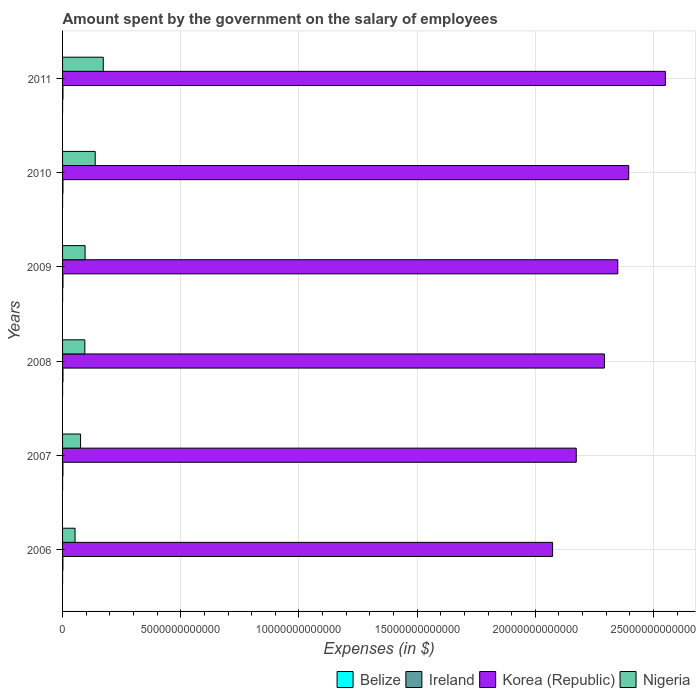How many different coloured bars are there?
Your answer should be compact. 4. How many groups of bars are there?
Provide a succinct answer. 6. Are the number of bars per tick equal to the number of legend labels?
Keep it short and to the point. Yes. Are the number of bars on each tick of the Y-axis equal?
Give a very brief answer. Yes. How many bars are there on the 6th tick from the top?
Provide a succinct answer. 4. What is the label of the 1st group of bars from the top?
Provide a short and direct response. 2011. In how many cases, is the number of bars for a given year not equal to the number of legend labels?
Offer a very short reply. 0. What is the amount spent on the salary of employees by the government in Belize in 2011?
Offer a terse response. 2.96e+08. Across all years, what is the maximum amount spent on the salary of employees by the government in Nigeria?
Provide a succinct answer. 1.72e+12. Across all years, what is the minimum amount spent on the salary of employees by the government in Korea (Republic)?
Make the answer very short. 2.07e+13. In which year was the amount spent on the salary of employees by the government in Korea (Republic) minimum?
Offer a very short reply. 2006. What is the total amount spent on the salary of employees by the government in Belize in the graph?
Give a very brief answer. 1.55e+09. What is the difference between the amount spent on the salary of employees by the government in Ireland in 2008 and that in 2009?
Ensure brevity in your answer.  2.99e+08. What is the difference between the amount spent on the salary of employees by the government in Korea (Republic) in 2009 and the amount spent on the salary of employees by the government in Nigeria in 2007?
Your response must be concise. 2.27e+13. What is the average amount spent on the salary of employees by the government in Ireland per year?
Give a very brief answer. 1.65e+1. In the year 2010, what is the difference between the amount spent on the salary of employees by the government in Belize and amount spent on the salary of employees by the government in Nigeria?
Give a very brief answer. -1.38e+12. In how many years, is the amount spent on the salary of employees by the government in Nigeria greater than 17000000000000 $?
Your answer should be very brief. 0. What is the ratio of the amount spent on the salary of employees by the government in Ireland in 2006 to that in 2008?
Provide a succinct answer. 0.81. Is the amount spent on the salary of employees by the government in Belize in 2007 less than that in 2010?
Ensure brevity in your answer.  Yes. What is the difference between the highest and the second highest amount spent on the salary of employees by the government in Ireland?
Make the answer very short. 2.99e+08. What is the difference between the highest and the lowest amount spent on the salary of employees by the government in Korea (Republic)?
Offer a terse response. 4.77e+12. Is it the case that in every year, the sum of the amount spent on the salary of employees by the government in Ireland and amount spent on the salary of employees by the government in Belize is greater than the sum of amount spent on the salary of employees by the government in Korea (Republic) and amount spent on the salary of employees by the government in Nigeria?
Provide a short and direct response. No. What does the 4th bar from the top in 2011 represents?
Ensure brevity in your answer.  Belize. What does the 1st bar from the bottom in 2009 represents?
Offer a terse response. Belize. How many bars are there?
Offer a terse response. 24. Are all the bars in the graph horizontal?
Your answer should be very brief. Yes. How many years are there in the graph?
Offer a terse response. 6. What is the difference between two consecutive major ticks on the X-axis?
Offer a terse response. 5.00e+12. Are the values on the major ticks of X-axis written in scientific E-notation?
Ensure brevity in your answer.  No. Where does the legend appear in the graph?
Give a very brief answer. Bottom right. What is the title of the graph?
Keep it short and to the point. Amount spent by the government on the salary of employees. Does "Latin America(developing only)" appear as one of the legend labels in the graph?
Give a very brief answer. No. What is the label or title of the X-axis?
Make the answer very short. Expenses (in $). What is the label or title of the Y-axis?
Make the answer very short. Years. What is the Expenses (in $) in Belize in 2006?
Keep it short and to the point. 2.19e+08. What is the Expenses (in $) of Ireland in 2006?
Offer a very short reply. 1.45e+1. What is the Expenses (in $) of Korea (Republic) in 2006?
Make the answer very short. 2.07e+13. What is the Expenses (in $) of Nigeria in 2006?
Offer a terse response. 5.28e+11. What is the Expenses (in $) in Belize in 2007?
Keep it short and to the point. 2.34e+08. What is the Expenses (in $) of Ireland in 2007?
Give a very brief answer. 1.59e+1. What is the Expenses (in $) in Korea (Republic) in 2007?
Make the answer very short. 2.17e+13. What is the Expenses (in $) in Nigeria in 2007?
Make the answer very short. 7.61e+11. What is the Expenses (in $) of Belize in 2008?
Keep it short and to the point. 2.50e+08. What is the Expenses (in $) of Ireland in 2008?
Your response must be concise. 1.80e+1. What is the Expenses (in $) of Korea (Republic) in 2008?
Ensure brevity in your answer.  2.29e+13. What is the Expenses (in $) in Nigeria in 2008?
Your response must be concise. 9.43e+11. What is the Expenses (in $) in Belize in 2009?
Offer a very short reply. 2.74e+08. What is the Expenses (in $) of Ireland in 2009?
Your response must be concise. 1.77e+1. What is the Expenses (in $) in Korea (Republic) in 2009?
Make the answer very short. 2.35e+13. What is the Expenses (in $) of Nigeria in 2009?
Give a very brief answer. 9.53e+11. What is the Expenses (in $) of Belize in 2010?
Make the answer very short. 2.79e+08. What is the Expenses (in $) of Ireland in 2010?
Your answer should be compact. 1.65e+1. What is the Expenses (in $) in Korea (Republic) in 2010?
Ensure brevity in your answer.  2.40e+13. What is the Expenses (in $) in Nigeria in 2010?
Provide a succinct answer. 1.38e+12. What is the Expenses (in $) in Belize in 2011?
Provide a short and direct response. 2.96e+08. What is the Expenses (in $) in Ireland in 2011?
Offer a very short reply. 1.63e+1. What is the Expenses (in $) of Korea (Republic) in 2011?
Your answer should be very brief. 2.55e+13. What is the Expenses (in $) in Nigeria in 2011?
Ensure brevity in your answer.  1.72e+12. Across all years, what is the maximum Expenses (in $) in Belize?
Offer a very short reply. 2.96e+08. Across all years, what is the maximum Expenses (in $) in Ireland?
Offer a terse response. 1.80e+1. Across all years, what is the maximum Expenses (in $) of Korea (Republic)?
Provide a succinct answer. 2.55e+13. Across all years, what is the maximum Expenses (in $) in Nigeria?
Provide a short and direct response. 1.72e+12. Across all years, what is the minimum Expenses (in $) in Belize?
Your answer should be compact. 2.19e+08. Across all years, what is the minimum Expenses (in $) of Ireland?
Keep it short and to the point. 1.45e+1. Across all years, what is the minimum Expenses (in $) in Korea (Republic)?
Offer a very short reply. 2.07e+13. Across all years, what is the minimum Expenses (in $) of Nigeria?
Provide a short and direct response. 5.28e+11. What is the total Expenses (in $) of Belize in the graph?
Offer a terse response. 1.55e+09. What is the total Expenses (in $) of Ireland in the graph?
Provide a short and direct response. 9.89e+1. What is the total Expenses (in $) of Korea (Republic) in the graph?
Your answer should be very brief. 1.38e+14. What is the total Expenses (in $) of Nigeria in the graph?
Ensure brevity in your answer.  6.29e+12. What is the difference between the Expenses (in $) of Belize in 2006 and that in 2007?
Your answer should be very brief. -1.45e+07. What is the difference between the Expenses (in $) in Ireland in 2006 and that in 2007?
Your answer should be very brief. -1.43e+09. What is the difference between the Expenses (in $) in Korea (Republic) in 2006 and that in 2007?
Provide a short and direct response. -1.00e+12. What is the difference between the Expenses (in $) in Nigeria in 2006 and that in 2007?
Keep it short and to the point. -2.33e+11. What is the difference between the Expenses (in $) of Belize in 2006 and that in 2008?
Provide a succinct answer. -3.06e+07. What is the difference between the Expenses (in $) in Ireland in 2006 and that in 2008?
Provide a succinct answer. -3.45e+09. What is the difference between the Expenses (in $) in Korea (Republic) in 2006 and that in 2008?
Your response must be concise. -2.19e+12. What is the difference between the Expenses (in $) in Nigeria in 2006 and that in 2008?
Provide a short and direct response. -4.15e+11. What is the difference between the Expenses (in $) of Belize in 2006 and that in 2009?
Give a very brief answer. -5.46e+07. What is the difference between the Expenses (in $) of Ireland in 2006 and that in 2009?
Your answer should be compact. -3.15e+09. What is the difference between the Expenses (in $) of Korea (Republic) in 2006 and that in 2009?
Your answer should be very brief. -2.76e+12. What is the difference between the Expenses (in $) in Nigeria in 2006 and that in 2009?
Your answer should be compact. -4.25e+11. What is the difference between the Expenses (in $) of Belize in 2006 and that in 2010?
Give a very brief answer. -5.96e+07. What is the difference between the Expenses (in $) of Ireland in 2006 and that in 2010?
Offer a terse response. -2.00e+09. What is the difference between the Expenses (in $) in Korea (Republic) in 2006 and that in 2010?
Your response must be concise. -3.22e+12. What is the difference between the Expenses (in $) in Nigeria in 2006 and that in 2010?
Your answer should be compact. -8.53e+11. What is the difference between the Expenses (in $) of Belize in 2006 and that in 2011?
Your answer should be compact. -7.70e+07. What is the difference between the Expenses (in $) of Ireland in 2006 and that in 2011?
Provide a succinct answer. -1.82e+09. What is the difference between the Expenses (in $) of Korea (Republic) in 2006 and that in 2011?
Make the answer very short. -4.77e+12. What is the difference between the Expenses (in $) of Nigeria in 2006 and that in 2011?
Ensure brevity in your answer.  -1.19e+12. What is the difference between the Expenses (in $) in Belize in 2007 and that in 2008?
Provide a short and direct response. -1.62e+07. What is the difference between the Expenses (in $) in Ireland in 2007 and that in 2008?
Your response must be concise. -2.02e+09. What is the difference between the Expenses (in $) of Korea (Republic) in 2007 and that in 2008?
Provide a succinct answer. -1.19e+12. What is the difference between the Expenses (in $) in Nigeria in 2007 and that in 2008?
Your answer should be compact. -1.82e+11. What is the difference between the Expenses (in $) of Belize in 2007 and that in 2009?
Keep it short and to the point. -4.01e+07. What is the difference between the Expenses (in $) of Ireland in 2007 and that in 2009?
Offer a terse response. -1.73e+09. What is the difference between the Expenses (in $) in Korea (Republic) in 2007 and that in 2009?
Your response must be concise. -1.76e+12. What is the difference between the Expenses (in $) of Nigeria in 2007 and that in 2009?
Your answer should be compact. -1.91e+11. What is the difference between the Expenses (in $) of Belize in 2007 and that in 2010?
Your response must be concise. -4.51e+07. What is the difference between the Expenses (in $) in Ireland in 2007 and that in 2010?
Offer a terse response. -5.68e+08. What is the difference between the Expenses (in $) in Korea (Republic) in 2007 and that in 2010?
Keep it short and to the point. -2.22e+12. What is the difference between the Expenses (in $) in Nigeria in 2007 and that in 2010?
Give a very brief answer. -6.19e+11. What is the difference between the Expenses (in $) in Belize in 2007 and that in 2011?
Provide a succinct answer. -6.25e+07. What is the difference between the Expenses (in $) of Ireland in 2007 and that in 2011?
Offer a terse response. -3.91e+08. What is the difference between the Expenses (in $) of Korea (Republic) in 2007 and that in 2011?
Make the answer very short. -3.77e+12. What is the difference between the Expenses (in $) in Nigeria in 2007 and that in 2011?
Provide a succinct answer. -9.61e+11. What is the difference between the Expenses (in $) in Belize in 2008 and that in 2009?
Your response must be concise. -2.39e+07. What is the difference between the Expenses (in $) in Ireland in 2008 and that in 2009?
Your answer should be very brief. 2.99e+08. What is the difference between the Expenses (in $) in Korea (Republic) in 2008 and that in 2009?
Make the answer very short. -5.65e+11. What is the difference between the Expenses (in $) in Nigeria in 2008 and that in 2009?
Ensure brevity in your answer.  -9.80e+09. What is the difference between the Expenses (in $) in Belize in 2008 and that in 2010?
Give a very brief answer. -2.89e+07. What is the difference between the Expenses (in $) of Ireland in 2008 and that in 2010?
Make the answer very short. 1.46e+09. What is the difference between the Expenses (in $) in Korea (Republic) in 2008 and that in 2010?
Ensure brevity in your answer.  -1.03e+12. What is the difference between the Expenses (in $) of Nigeria in 2008 and that in 2010?
Ensure brevity in your answer.  -4.38e+11. What is the difference between the Expenses (in $) of Belize in 2008 and that in 2011?
Give a very brief answer. -4.63e+07. What is the difference between the Expenses (in $) in Ireland in 2008 and that in 2011?
Your response must be concise. 1.63e+09. What is the difference between the Expenses (in $) in Korea (Republic) in 2008 and that in 2011?
Your response must be concise. -2.58e+12. What is the difference between the Expenses (in $) of Nigeria in 2008 and that in 2011?
Make the answer very short. -7.80e+11. What is the difference between the Expenses (in $) in Belize in 2009 and that in 2010?
Give a very brief answer. -5.02e+06. What is the difference between the Expenses (in $) in Ireland in 2009 and that in 2010?
Offer a very short reply. 1.16e+09. What is the difference between the Expenses (in $) of Korea (Republic) in 2009 and that in 2010?
Offer a very short reply. -4.62e+11. What is the difference between the Expenses (in $) in Nigeria in 2009 and that in 2010?
Provide a succinct answer. -4.28e+11. What is the difference between the Expenses (in $) in Belize in 2009 and that in 2011?
Offer a terse response. -2.24e+07. What is the difference between the Expenses (in $) in Ireland in 2009 and that in 2011?
Offer a very short reply. 1.33e+09. What is the difference between the Expenses (in $) in Korea (Republic) in 2009 and that in 2011?
Make the answer very short. -2.01e+12. What is the difference between the Expenses (in $) of Nigeria in 2009 and that in 2011?
Give a very brief answer. -7.70e+11. What is the difference between the Expenses (in $) in Belize in 2010 and that in 2011?
Offer a terse response. -1.74e+07. What is the difference between the Expenses (in $) of Ireland in 2010 and that in 2011?
Give a very brief answer. 1.77e+08. What is the difference between the Expenses (in $) in Korea (Republic) in 2010 and that in 2011?
Your response must be concise. -1.55e+12. What is the difference between the Expenses (in $) of Nigeria in 2010 and that in 2011?
Provide a succinct answer. -3.42e+11. What is the difference between the Expenses (in $) of Belize in 2006 and the Expenses (in $) of Ireland in 2007?
Provide a succinct answer. -1.57e+1. What is the difference between the Expenses (in $) in Belize in 2006 and the Expenses (in $) in Korea (Republic) in 2007?
Your response must be concise. -2.17e+13. What is the difference between the Expenses (in $) in Belize in 2006 and the Expenses (in $) in Nigeria in 2007?
Your answer should be very brief. -7.61e+11. What is the difference between the Expenses (in $) of Ireland in 2006 and the Expenses (in $) of Korea (Republic) in 2007?
Your answer should be compact. -2.17e+13. What is the difference between the Expenses (in $) in Ireland in 2006 and the Expenses (in $) in Nigeria in 2007?
Your response must be concise. -7.47e+11. What is the difference between the Expenses (in $) of Korea (Republic) in 2006 and the Expenses (in $) of Nigeria in 2007?
Ensure brevity in your answer.  2.00e+13. What is the difference between the Expenses (in $) in Belize in 2006 and the Expenses (in $) in Ireland in 2008?
Offer a very short reply. -1.77e+1. What is the difference between the Expenses (in $) of Belize in 2006 and the Expenses (in $) of Korea (Republic) in 2008?
Offer a terse response. -2.29e+13. What is the difference between the Expenses (in $) in Belize in 2006 and the Expenses (in $) in Nigeria in 2008?
Give a very brief answer. -9.43e+11. What is the difference between the Expenses (in $) in Ireland in 2006 and the Expenses (in $) in Korea (Republic) in 2008?
Make the answer very short. -2.29e+13. What is the difference between the Expenses (in $) of Ireland in 2006 and the Expenses (in $) of Nigeria in 2008?
Provide a short and direct response. -9.28e+11. What is the difference between the Expenses (in $) of Korea (Republic) in 2006 and the Expenses (in $) of Nigeria in 2008?
Ensure brevity in your answer.  1.98e+13. What is the difference between the Expenses (in $) of Belize in 2006 and the Expenses (in $) of Ireland in 2009?
Provide a short and direct response. -1.74e+1. What is the difference between the Expenses (in $) in Belize in 2006 and the Expenses (in $) in Korea (Republic) in 2009?
Your answer should be very brief. -2.35e+13. What is the difference between the Expenses (in $) in Belize in 2006 and the Expenses (in $) in Nigeria in 2009?
Offer a very short reply. -9.52e+11. What is the difference between the Expenses (in $) of Ireland in 2006 and the Expenses (in $) of Korea (Republic) in 2009?
Provide a short and direct response. -2.35e+13. What is the difference between the Expenses (in $) of Ireland in 2006 and the Expenses (in $) of Nigeria in 2009?
Provide a succinct answer. -9.38e+11. What is the difference between the Expenses (in $) in Korea (Republic) in 2006 and the Expenses (in $) in Nigeria in 2009?
Your response must be concise. 1.98e+13. What is the difference between the Expenses (in $) of Belize in 2006 and the Expenses (in $) of Ireland in 2010?
Your answer should be very brief. -1.63e+1. What is the difference between the Expenses (in $) in Belize in 2006 and the Expenses (in $) in Korea (Republic) in 2010?
Provide a short and direct response. -2.40e+13. What is the difference between the Expenses (in $) in Belize in 2006 and the Expenses (in $) in Nigeria in 2010?
Your response must be concise. -1.38e+12. What is the difference between the Expenses (in $) in Ireland in 2006 and the Expenses (in $) in Korea (Republic) in 2010?
Your answer should be very brief. -2.39e+13. What is the difference between the Expenses (in $) of Ireland in 2006 and the Expenses (in $) of Nigeria in 2010?
Make the answer very short. -1.37e+12. What is the difference between the Expenses (in $) of Korea (Republic) in 2006 and the Expenses (in $) of Nigeria in 2010?
Your answer should be very brief. 1.94e+13. What is the difference between the Expenses (in $) in Belize in 2006 and the Expenses (in $) in Ireland in 2011?
Your response must be concise. -1.61e+1. What is the difference between the Expenses (in $) in Belize in 2006 and the Expenses (in $) in Korea (Republic) in 2011?
Provide a short and direct response. -2.55e+13. What is the difference between the Expenses (in $) of Belize in 2006 and the Expenses (in $) of Nigeria in 2011?
Your response must be concise. -1.72e+12. What is the difference between the Expenses (in $) in Ireland in 2006 and the Expenses (in $) in Korea (Republic) in 2011?
Provide a succinct answer. -2.55e+13. What is the difference between the Expenses (in $) in Ireland in 2006 and the Expenses (in $) in Nigeria in 2011?
Make the answer very short. -1.71e+12. What is the difference between the Expenses (in $) in Korea (Republic) in 2006 and the Expenses (in $) in Nigeria in 2011?
Offer a terse response. 1.90e+13. What is the difference between the Expenses (in $) in Belize in 2007 and the Expenses (in $) in Ireland in 2008?
Provide a short and direct response. -1.77e+1. What is the difference between the Expenses (in $) of Belize in 2007 and the Expenses (in $) of Korea (Republic) in 2008?
Your answer should be compact. -2.29e+13. What is the difference between the Expenses (in $) of Belize in 2007 and the Expenses (in $) of Nigeria in 2008?
Your answer should be very brief. -9.43e+11. What is the difference between the Expenses (in $) in Ireland in 2007 and the Expenses (in $) in Korea (Republic) in 2008?
Offer a terse response. -2.29e+13. What is the difference between the Expenses (in $) of Ireland in 2007 and the Expenses (in $) of Nigeria in 2008?
Your response must be concise. -9.27e+11. What is the difference between the Expenses (in $) in Korea (Republic) in 2007 and the Expenses (in $) in Nigeria in 2008?
Keep it short and to the point. 2.08e+13. What is the difference between the Expenses (in $) in Belize in 2007 and the Expenses (in $) in Ireland in 2009?
Provide a short and direct response. -1.74e+1. What is the difference between the Expenses (in $) in Belize in 2007 and the Expenses (in $) in Korea (Republic) in 2009?
Keep it short and to the point. -2.35e+13. What is the difference between the Expenses (in $) of Belize in 2007 and the Expenses (in $) of Nigeria in 2009?
Offer a very short reply. -9.52e+11. What is the difference between the Expenses (in $) in Ireland in 2007 and the Expenses (in $) in Korea (Republic) in 2009?
Your answer should be very brief. -2.35e+13. What is the difference between the Expenses (in $) of Ireland in 2007 and the Expenses (in $) of Nigeria in 2009?
Give a very brief answer. -9.37e+11. What is the difference between the Expenses (in $) of Korea (Republic) in 2007 and the Expenses (in $) of Nigeria in 2009?
Offer a very short reply. 2.08e+13. What is the difference between the Expenses (in $) of Belize in 2007 and the Expenses (in $) of Ireland in 2010?
Make the answer very short. -1.63e+1. What is the difference between the Expenses (in $) in Belize in 2007 and the Expenses (in $) in Korea (Republic) in 2010?
Provide a succinct answer. -2.40e+13. What is the difference between the Expenses (in $) of Belize in 2007 and the Expenses (in $) of Nigeria in 2010?
Provide a short and direct response. -1.38e+12. What is the difference between the Expenses (in $) in Ireland in 2007 and the Expenses (in $) in Korea (Republic) in 2010?
Give a very brief answer. -2.39e+13. What is the difference between the Expenses (in $) in Ireland in 2007 and the Expenses (in $) in Nigeria in 2010?
Your answer should be compact. -1.36e+12. What is the difference between the Expenses (in $) of Korea (Republic) in 2007 and the Expenses (in $) of Nigeria in 2010?
Ensure brevity in your answer.  2.04e+13. What is the difference between the Expenses (in $) of Belize in 2007 and the Expenses (in $) of Ireland in 2011?
Make the answer very short. -1.61e+1. What is the difference between the Expenses (in $) of Belize in 2007 and the Expenses (in $) of Korea (Republic) in 2011?
Keep it short and to the point. -2.55e+13. What is the difference between the Expenses (in $) of Belize in 2007 and the Expenses (in $) of Nigeria in 2011?
Offer a terse response. -1.72e+12. What is the difference between the Expenses (in $) of Ireland in 2007 and the Expenses (in $) of Korea (Republic) in 2011?
Make the answer very short. -2.55e+13. What is the difference between the Expenses (in $) of Ireland in 2007 and the Expenses (in $) of Nigeria in 2011?
Your answer should be compact. -1.71e+12. What is the difference between the Expenses (in $) in Korea (Republic) in 2007 and the Expenses (in $) in Nigeria in 2011?
Your answer should be very brief. 2.00e+13. What is the difference between the Expenses (in $) in Belize in 2008 and the Expenses (in $) in Ireland in 2009?
Your answer should be very brief. -1.74e+1. What is the difference between the Expenses (in $) in Belize in 2008 and the Expenses (in $) in Korea (Republic) in 2009?
Offer a terse response. -2.35e+13. What is the difference between the Expenses (in $) of Belize in 2008 and the Expenses (in $) of Nigeria in 2009?
Give a very brief answer. -9.52e+11. What is the difference between the Expenses (in $) in Ireland in 2008 and the Expenses (in $) in Korea (Republic) in 2009?
Your response must be concise. -2.35e+13. What is the difference between the Expenses (in $) of Ireland in 2008 and the Expenses (in $) of Nigeria in 2009?
Make the answer very short. -9.35e+11. What is the difference between the Expenses (in $) in Korea (Republic) in 2008 and the Expenses (in $) in Nigeria in 2009?
Your response must be concise. 2.20e+13. What is the difference between the Expenses (in $) in Belize in 2008 and the Expenses (in $) in Ireland in 2010?
Offer a terse response. -1.63e+1. What is the difference between the Expenses (in $) in Belize in 2008 and the Expenses (in $) in Korea (Republic) in 2010?
Provide a short and direct response. -2.40e+13. What is the difference between the Expenses (in $) of Belize in 2008 and the Expenses (in $) of Nigeria in 2010?
Make the answer very short. -1.38e+12. What is the difference between the Expenses (in $) in Ireland in 2008 and the Expenses (in $) in Korea (Republic) in 2010?
Provide a succinct answer. -2.39e+13. What is the difference between the Expenses (in $) in Ireland in 2008 and the Expenses (in $) in Nigeria in 2010?
Your response must be concise. -1.36e+12. What is the difference between the Expenses (in $) in Korea (Republic) in 2008 and the Expenses (in $) in Nigeria in 2010?
Offer a very short reply. 2.15e+13. What is the difference between the Expenses (in $) of Belize in 2008 and the Expenses (in $) of Ireland in 2011?
Your response must be concise. -1.61e+1. What is the difference between the Expenses (in $) in Belize in 2008 and the Expenses (in $) in Korea (Republic) in 2011?
Keep it short and to the point. -2.55e+13. What is the difference between the Expenses (in $) in Belize in 2008 and the Expenses (in $) in Nigeria in 2011?
Your response must be concise. -1.72e+12. What is the difference between the Expenses (in $) in Ireland in 2008 and the Expenses (in $) in Korea (Republic) in 2011?
Offer a terse response. -2.55e+13. What is the difference between the Expenses (in $) in Ireland in 2008 and the Expenses (in $) in Nigeria in 2011?
Offer a very short reply. -1.70e+12. What is the difference between the Expenses (in $) in Korea (Republic) in 2008 and the Expenses (in $) in Nigeria in 2011?
Your answer should be very brief. 2.12e+13. What is the difference between the Expenses (in $) of Belize in 2009 and the Expenses (in $) of Ireland in 2010?
Ensure brevity in your answer.  -1.62e+1. What is the difference between the Expenses (in $) in Belize in 2009 and the Expenses (in $) in Korea (Republic) in 2010?
Provide a succinct answer. -2.40e+13. What is the difference between the Expenses (in $) of Belize in 2009 and the Expenses (in $) of Nigeria in 2010?
Offer a very short reply. -1.38e+12. What is the difference between the Expenses (in $) in Ireland in 2009 and the Expenses (in $) in Korea (Republic) in 2010?
Give a very brief answer. -2.39e+13. What is the difference between the Expenses (in $) of Ireland in 2009 and the Expenses (in $) of Nigeria in 2010?
Offer a terse response. -1.36e+12. What is the difference between the Expenses (in $) of Korea (Republic) in 2009 and the Expenses (in $) of Nigeria in 2010?
Make the answer very short. 2.21e+13. What is the difference between the Expenses (in $) in Belize in 2009 and the Expenses (in $) in Ireland in 2011?
Your answer should be compact. -1.61e+1. What is the difference between the Expenses (in $) of Belize in 2009 and the Expenses (in $) of Korea (Republic) in 2011?
Keep it short and to the point. -2.55e+13. What is the difference between the Expenses (in $) in Belize in 2009 and the Expenses (in $) in Nigeria in 2011?
Keep it short and to the point. -1.72e+12. What is the difference between the Expenses (in $) of Ireland in 2009 and the Expenses (in $) of Korea (Republic) in 2011?
Provide a short and direct response. -2.55e+13. What is the difference between the Expenses (in $) of Ireland in 2009 and the Expenses (in $) of Nigeria in 2011?
Your answer should be compact. -1.70e+12. What is the difference between the Expenses (in $) in Korea (Republic) in 2009 and the Expenses (in $) in Nigeria in 2011?
Provide a short and direct response. 2.18e+13. What is the difference between the Expenses (in $) in Belize in 2010 and the Expenses (in $) in Ireland in 2011?
Make the answer very short. -1.60e+1. What is the difference between the Expenses (in $) in Belize in 2010 and the Expenses (in $) in Korea (Republic) in 2011?
Offer a very short reply. -2.55e+13. What is the difference between the Expenses (in $) in Belize in 2010 and the Expenses (in $) in Nigeria in 2011?
Your response must be concise. -1.72e+12. What is the difference between the Expenses (in $) of Ireland in 2010 and the Expenses (in $) of Korea (Republic) in 2011?
Your answer should be very brief. -2.55e+13. What is the difference between the Expenses (in $) of Ireland in 2010 and the Expenses (in $) of Nigeria in 2011?
Offer a very short reply. -1.71e+12. What is the difference between the Expenses (in $) of Korea (Republic) in 2010 and the Expenses (in $) of Nigeria in 2011?
Your response must be concise. 2.22e+13. What is the average Expenses (in $) in Belize per year?
Ensure brevity in your answer.  2.59e+08. What is the average Expenses (in $) of Ireland per year?
Ensure brevity in your answer.  1.65e+1. What is the average Expenses (in $) of Korea (Republic) per year?
Ensure brevity in your answer.  2.31e+13. What is the average Expenses (in $) in Nigeria per year?
Ensure brevity in your answer.  1.05e+12. In the year 2006, what is the difference between the Expenses (in $) of Belize and Expenses (in $) of Ireland?
Provide a short and direct response. -1.43e+1. In the year 2006, what is the difference between the Expenses (in $) in Belize and Expenses (in $) in Korea (Republic)?
Keep it short and to the point. -2.07e+13. In the year 2006, what is the difference between the Expenses (in $) of Belize and Expenses (in $) of Nigeria?
Provide a succinct answer. -5.28e+11. In the year 2006, what is the difference between the Expenses (in $) in Ireland and Expenses (in $) in Korea (Republic)?
Your answer should be very brief. -2.07e+13. In the year 2006, what is the difference between the Expenses (in $) in Ireland and Expenses (in $) in Nigeria?
Give a very brief answer. -5.13e+11. In the year 2006, what is the difference between the Expenses (in $) of Korea (Republic) and Expenses (in $) of Nigeria?
Provide a succinct answer. 2.02e+13. In the year 2007, what is the difference between the Expenses (in $) of Belize and Expenses (in $) of Ireland?
Offer a very short reply. -1.57e+1. In the year 2007, what is the difference between the Expenses (in $) in Belize and Expenses (in $) in Korea (Republic)?
Offer a very short reply. -2.17e+13. In the year 2007, what is the difference between the Expenses (in $) of Belize and Expenses (in $) of Nigeria?
Your response must be concise. -7.61e+11. In the year 2007, what is the difference between the Expenses (in $) of Ireland and Expenses (in $) of Korea (Republic)?
Provide a succinct answer. -2.17e+13. In the year 2007, what is the difference between the Expenses (in $) of Ireland and Expenses (in $) of Nigeria?
Ensure brevity in your answer.  -7.45e+11. In the year 2007, what is the difference between the Expenses (in $) in Korea (Republic) and Expenses (in $) in Nigeria?
Keep it short and to the point. 2.10e+13. In the year 2008, what is the difference between the Expenses (in $) of Belize and Expenses (in $) of Ireland?
Provide a short and direct response. -1.77e+1. In the year 2008, what is the difference between the Expenses (in $) of Belize and Expenses (in $) of Korea (Republic)?
Ensure brevity in your answer.  -2.29e+13. In the year 2008, what is the difference between the Expenses (in $) in Belize and Expenses (in $) in Nigeria?
Offer a very short reply. -9.43e+11. In the year 2008, what is the difference between the Expenses (in $) of Ireland and Expenses (in $) of Korea (Republic)?
Provide a succinct answer. -2.29e+13. In the year 2008, what is the difference between the Expenses (in $) of Ireland and Expenses (in $) of Nigeria?
Your response must be concise. -9.25e+11. In the year 2008, what is the difference between the Expenses (in $) of Korea (Republic) and Expenses (in $) of Nigeria?
Offer a very short reply. 2.20e+13. In the year 2009, what is the difference between the Expenses (in $) in Belize and Expenses (in $) in Ireland?
Your response must be concise. -1.74e+1. In the year 2009, what is the difference between the Expenses (in $) in Belize and Expenses (in $) in Korea (Republic)?
Ensure brevity in your answer.  -2.35e+13. In the year 2009, what is the difference between the Expenses (in $) of Belize and Expenses (in $) of Nigeria?
Offer a very short reply. -9.52e+11. In the year 2009, what is the difference between the Expenses (in $) in Ireland and Expenses (in $) in Korea (Republic)?
Offer a terse response. -2.35e+13. In the year 2009, what is the difference between the Expenses (in $) of Ireland and Expenses (in $) of Nigeria?
Your answer should be compact. -9.35e+11. In the year 2009, what is the difference between the Expenses (in $) of Korea (Republic) and Expenses (in $) of Nigeria?
Your answer should be very brief. 2.25e+13. In the year 2010, what is the difference between the Expenses (in $) of Belize and Expenses (in $) of Ireland?
Ensure brevity in your answer.  -1.62e+1. In the year 2010, what is the difference between the Expenses (in $) in Belize and Expenses (in $) in Korea (Republic)?
Your response must be concise. -2.40e+13. In the year 2010, what is the difference between the Expenses (in $) of Belize and Expenses (in $) of Nigeria?
Give a very brief answer. -1.38e+12. In the year 2010, what is the difference between the Expenses (in $) of Ireland and Expenses (in $) of Korea (Republic)?
Keep it short and to the point. -2.39e+13. In the year 2010, what is the difference between the Expenses (in $) in Ireland and Expenses (in $) in Nigeria?
Your response must be concise. -1.36e+12. In the year 2010, what is the difference between the Expenses (in $) in Korea (Republic) and Expenses (in $) in Nigeria?
Offer a terse response. 2.26e+13. In the year 2011, what is the difference between the Expenses (in $) in Belize and Expenses (in $) in Ireland?
Keep it short and to the point. -1.60e+1. In the year 2011, what is the difference between the Expenses (in $) of Belize and Expenses (in $) of Korea (Republic)?
Provide a succinct answer. -2.55e+13. In the year 2011, what is the difference between the Expenses (in $) in Belize and Expenses (in $) in Nigeria?
Provide a succinct answer. -1.72e+12. In the year 2011, what is the difference between the Expenses (in $) in Ireland and Expenses (in $) in Korea (Republic)?
Make the answer very short. -2.55e+13. In the year 2011, what is the difference between the Expenses (in $) in Ireland and Expenses (in $) in Nigeria?
Ensure brevity in your answer.  -1.71e+12. In the year 2011, what is the difference between the Expenses (in $) in Korea (Republic) and Expenses (in $) in Nigeria?
Your answer should be compact. 2.38e+13. What is the ratio of the Expenses (in $) of Belize in 2006 to that in 2007?
Your answer should be compact. 0.94. What is the ratio of the Expenses (in $) in Ireland in 2006 to that in 2007?
Keep it short and to the point. 0.91. What is the ratio of the Expenses (in $) of Korea (Republic) in 2006 to that in 2007?
Give a very brief answer. 0.95. What is the ratio of the Expenses (in $) in Nigeria in 2006 to that in 2007?
Give a very brief answer. 0.69. What is the ratio of the Expenses (in $) in Belize in 2006 to that in 2008?
Offer a very short reply. 0.88. What is the ratio of the Expenses (in $) of Ireland in 2006 to that in 2008?
Provide a succinct answer. 0.81. What is the ratio of the Expenses (in $) of Korea (Republic) in 2006 to that in 2008?
Offer a terse response. 0.9. What is the ratio of the Expenses (in $) of Nigeria in 2006 to that in 2008?
Ensure brevity in your answer.  0.56. What is the ratio of the Expenses (in $) of Belize in 2006 to that in 2009?
Offer a very short reply. 0.8. What is the ratio of the Expenses (in $) of Ireland in 2006 to that in 2009?
Ensure brevity in your answer.  0.82. What is the ratio of the Expenses (in $) of Korea (Republic) in 2006 to that in 2009?
Ensure brevity in your answer.  0.88. What is the ratio of the Expenses (in $) in Nigeria in 2006 to that in 2009?
Make the answer very short. 0.55. What is the ratio of the Expenses (in $) of Belize in 2006 to that in 2010?
Your answer should be compact. 0.79. What is the ratio of the Expenses (in $) of Ireland in 2006 to that in 2010?
Give a very brief answer. 0.88. What is the ratio of the Expenses (in $) in Korea (Republic) in 2006 to that in 2010?
Keep it short and to the point. 0.87. What is the ratio of the Expenses (in $) in Nigeria in 2006 to that in 2010?
Offer a terse response. 0.38. What is the ratio of the Expenses (in $) in Belize in 2006 to that in 2011?
Your response must be concise. 0.74. What is the ratio of the Expenses (in $) of Ireland in 2006 to that in 2011?
Your response must be concise. 0.89. What is the ratio of the Expenses (in $) in Korea (Republic) in 2006 to that in 2011?
Provide a succinct answer. 0.81. What is the ratio of the Expenses (in $) in Nigeria in 2006 to that in 2011?
Your answer should be compact. 0.31. What is the ratio of the Expenses (in $) of Belize in 2007 to that in 2008?
Offer a very short reply. 0.94. What is the ratio of the Expenses (in $) in Ireland in 2007 to that in 2008?
Keep it short and to the point. 0.89. What is the ratio of the Expenses (in $) of Korea (Republic) in 2007 to that in 2008?
Provide a short and direct response. 0.95. What is the ratio of the Expenses (in $) in Nigeria in 2007 to that in 2008?
Offer a very short reply. 0.81. What is the ratio of the Expenses (in $) in Belize in 2007 to that in 2009?
Your response must be concise. 0.85. What is the ratio of the Expenses (in $) in Ireland in 2007 to that in 2009?
Ensure brevity in your answer.  0.9. What is the ratio of the Expenses (in $) in Korea (Republic) in 2007 to that in 2009?
Provide a short and direct response. 0.93. What is the ratio of the Expenses (in $) of Nigeria in 2007 to that in 2009?
Make the answer very short. 0.8. What is the ratio of the Expenses (in $) in Belize in 2007 to that in 2010?
Your answer should be compact. 0.84. What is the ratio of the Expenses (in $) of Ireland in 2007 to that in 2010?
Your answer should be compact. 0.97. What is the ratio of the Expenses (in $) of Korea (Republic) in 2007 to that in 2010?
Offer a terse response. 0.91. What is the ratio of the Expenses (in $) of Nigeria in 2007 to that in 2010?
Offer a terse response. 0.55. What is the ratio of the Expenses (in $) of Belize in 2007 to that in 2011?
Make the answer very short. 0.79. What is the ratio of the Expenses (in $) in Korea (Republic) in 2007 to that in 2011?
Make the answer very short. 0.85. What is the ratio of the Expenses (in $) of Nigeria in 2007 to that in 2011?
Offer a very short reply. 0.44. What is the ratio of the Expenses (in $) in Belize in 2008 to that in 2009?
Your answer should be very brief. 0.91. What is the ratio of the Expenses (in $) of Ireland in 2008 to that in 2009?
Offer a terse response. 1.02. What is the ratio of the Expenses (in $) in Korea (Republic) in 2008 to that in 2009?
Provide a succinct answer. 0.98. What is the ratio of the Expenses (in $) in Nigeria in 2008 to that in 2009?
Your answer should be very brief. 0.99. What is the ratio of the Expenses (in $) of Belize in 2008 to that in 2010?
Give a very brief answer. 0.9. What is the ratio of the Expenses (in $) in Ireland in 2008 to that in 2010?
Offer a terse response. 1.09. What is the ratio of the Expenses (in $) in Korea (Republic) in 2008 to that in 2010?
Keep it short and to the point. 0.96. What is the ratio of the Expenses (in $) of Nigeria in 2008 to that in 2010?
Make the answer very short. 0.68. What is the ratio of the Expenses (in $) of Belize in 2008 to that in 2011?
Your answer should be compact. 0.84. What is the ratio of the Expenses (in $) in Korea (Republic) in 2008 to that in 2011?
Ensure brevity in your answer.  0.9. What is the ratio of the Expenses (in $) in Nigeria in 2008 to that in 2011?
Your answer should be compact. 0.55. What is the ratio of the Expenses (in $) of Belize in 2009 to that in 2010?
Give a very brief answer. 0.98. What is the ratio of the Expenses (in $) in Ireland in 2009 to that in 2010?
Offer a terse response. 1.07. What is the ratio of the Expenses (in $) of Korea (Republic) in 2009 to that in 2010?
Your answer should be compact. 0.98. What is the ratio of the Expenses (in $) of Nigeria in 2009 to that in 2010?
Ensure brevity in your answer.  0.69. What is the ratio of the Expenses (in $) in Belize in 2009 to that in 2011?
Provide a short and direct response. 0.92. What is the ratio of the Expenses (in $) in Ireland in 2009 to that in 2011?
Give a very brief answer. 1.08. What is the ratio of the Expenses (in $) in Korea (Republic) in 2009 to that in 2011?
Your answer should be compact. 0.92. What is the ratio of the Expenses (in $) in Nigeria in 2009 to that in 2011?
Offer a terse response. 0.55. What is the ratio of the Expenses (in $) in Belize in 2010 to that in 2011?
Your answer should be very brief. 0.94. What is the ratio of the Expenses (in $) in Ireland in 2010 to that in 2011?
Your answer should be very brief. 1.01. What is the ratio of the Expenses (in $) of Korea (Republic) in 2010 to that in 2011?
Your answer should be compact. 0.94. What is the ratio of the Expenses (in $) in Nigeria in 2010 to that in 2011?
Make the answer very short. 0.8. What is the difference between the highest and the second highest Expenses (in $) of Belize?
Give a very brief answer. 1.74e+07. What is the difference between the highest and the second highest Expenses (in $) in Ireland?
Give a very brief answer. 2.99e+08. What is the difference between the highest and the second highest Expenses (in $) in Korea (Republic)?
Provide a succinct answer. 1.55e+12. What is the difference between the highest and the second highest Expenses (in $) in Nigeria?
Your response must be concise. 3.42e+11. What is the difference between the highest and the lowest Expenses (in $) in Belize?
Provide a succinct answer. 7.70e+07. What is the difference between the highest and the lowest Expenses (in $) of Ireland?
Give a very brief answer. 3.45e+09. What is the difference between the highest and the lowest Expenses (in $) in Korea (Republic)?
Your answer should be compact. 4.77e+12. What is the difference between the highest and the lowest Expenses (in $) of Nigeria?
Your response must be concise. 1.19e+12. 